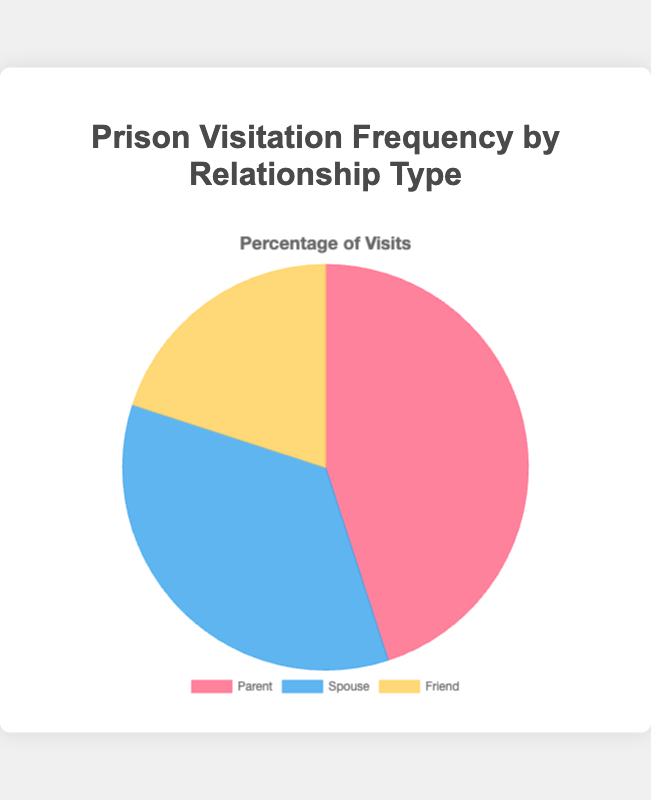What percentage of visits are made by parents? The pie chart shows that parents account for 45% of all visits.
Answer: 45% What percentage of visits are made by spouses? The pie chart shows that spouses account for 35% of all visits.
Answer: 35% What percentage of visits are made by friends? The pie chart shows that friends account for 20% of all visits.
Answer: 20% Which relationship type has the highest visitation frequency? By observing the pie chart, the largest segment is labeled 'Parent' with 45%, indicating the highest visitation frequency.
Answer: Parent Which relationship type has the lowest visitation frequency? The smallest segment in the pie chart is labeled 'Friend' with 20%, indicating the lowest visitation frequency.
Answer: Friend How much greater is the visitation frequency by parents than by spouses? The visitation frequency by parents is 45% and by spouses is 35%, so the difference is 45% - 35% = 10%.
Answer: 10% How much greater is the visitation frequency by parents than by friends? The visitation frequency by parents is 45% and by friends is 20%, so the difference is 45% - 20% = 25%.
Answer: 25% What is the combined percentage of visits made by parents and friends? The pie chart shows parents at 45% and friends at 20%, so the combined percentage is 45% + 20% = 65%.
Answer: 65% How much smaller is the visitation frequency by friends compared to spouses? The pie chart shows friends at 20% and spouses at 35%, so the difference is 35% - 20% = 15%.
Answer: 15% What is the average percentage of visits across all relationship types displayed in the chart? The percentages for parents, spouses, and friends are 45%, 35%, and 20%, respectively. The average is (45% + 35% + 20%) / 3 = 100% / 3 ≈ 33.33%.
Answer: 33.33% 